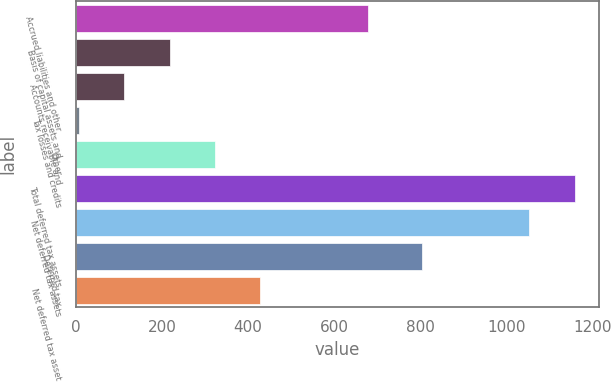Convert chart to OTSL. <chart><loc_0><loc_0><loc_500><loc_500><bar_chart><fcel>Accrued liabilities and other<fcel>Basis of capital assets and<fcel>Accounts receivable and<fcel>Tax losses and credits<fcel>Other<fcel>Total deferred tax assets<fcel>Net deferred tax assets<fcel>Deferred tax<fcel>Net deferred tax asset<nl><fcel>679<fcel>218<fcel>113<fcel>8<fcel>323<fcel>1158<fcel>1053<fcel>803<fcel>428<nl></chart> 